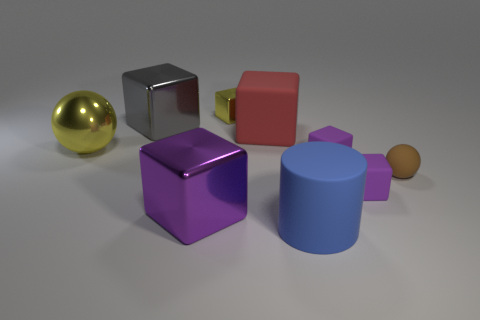Can you tell me which object appears to be the smoothest and which looks the roughest in terms of texture? The golden sphere on the left seems to have the smoothest texture with a reflective surface, while the larger gray cube appears to have a slightly rougher matte finish. 